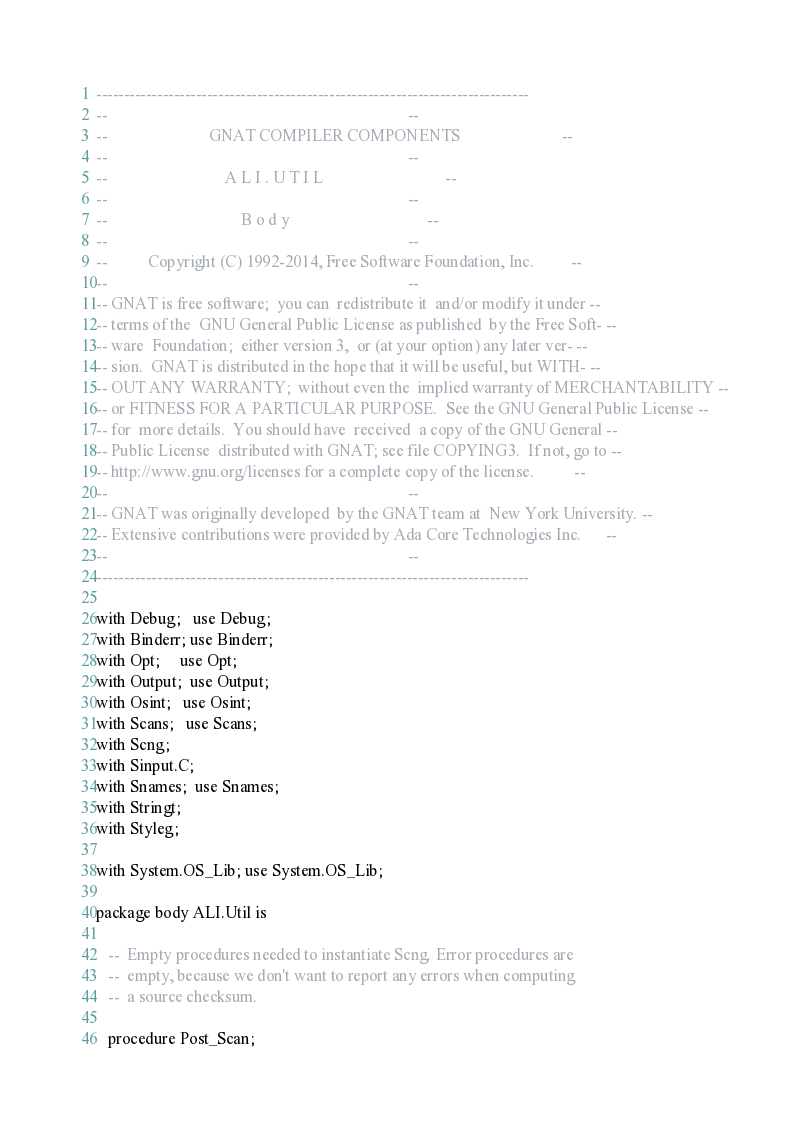<code> <loc_0><loc_0><loc_500><loc_500><_Ada_>------------------------------------------------------------------------------
--                                                                          --
--                         GNAT COMPILER COMPONENTS                         --
--                                                                          --
--                             A L I . U T I L                              --
--                                                                          --
--                                 B o d y                                  --
--                                                                          --
--          Copyright (C) 1992-2014, Free Software Foundation, Inc.         --
--                                                                          --
-- GNAT is free software;  you can  redistribute it  and/or modify it under --
-- terms of the  GNU General Public License as published  by the Free Soft- --
-- ware  Foundation;  either version 3,  or (at your option) any later ver- --
-- sion.  GNAT is distributed in the hope that it will be useful, but WITH- --
-- OUT ANY WARRANTY;  without even the  implied warranty of MERCHANTABILITY --
-- or FITNESS FOR A PARTICULAR PURPOSE.  See the GNU General Public License --
-- for  more details.  You should have  received  a copy of the GNU General --
-- Public License  distributed with GNAT; see file COPYING3.  If not, go to --
-- http://www.gnu.org/licenses for a complete copy of the license.          --
--                                                                          --
-- GNAT was originally developed  by the GNAT team at  New York University. --
-- Extensive contributions were provided by Ada Core Technologies Inc.      --
--                                                                          --
------------------------------------------------------------------------------

with Debug;   use Debug;
with Binderr; use Binderr;
with Opt;     use Opt;
with Output;  use Output;
with Osint;   use Osint;
with Scans;   use Scans;
with Scng;
with Sinput.C;
with Snames;  use Snames;
with Stringt;
with Styleg;

with System.OS_Lib; use System.OS_Lib;

package body ALI.Util is

   --  Empty procedures needed to instantiate Scng. Error procedures are
   --  empty, because we don't want to report any errors when computing
   --  a source checksum.

   procedure Post_Scan;
</code> 